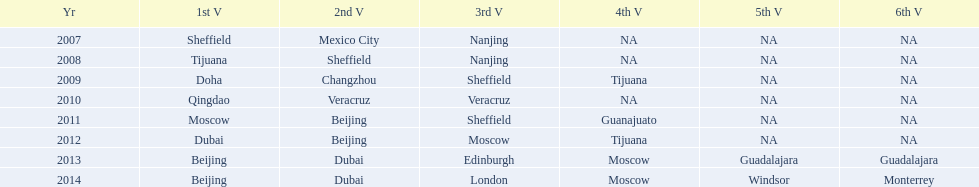What was the last year where tijuana was a venue? 2012. 